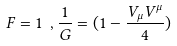<formula> <loc_0><loc_0><loc_500><loc_500>F = 1 \ , \frac { 1 } { G } = ( 1 - \frac { V _ { \mu } V ^ { \mu } } { 4 } ) \</formula> 